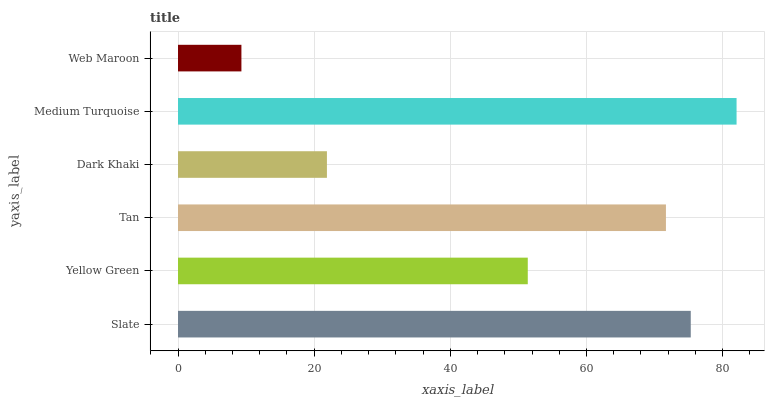Is Web Maroon the minimum?
Answer yes or no. Yes. Is Medium Turquoise the maximum?
Answer yes or no. Yes. Is Yellow Green the minimum?
Answer yes or no. No. Is Yellow Green the maximum?
Answer yes or no. No. Is Slate greater than Yellow Green?
Answer yes or no. Yes. Is Yellow Green less than Slate?
Answer yes or no. Yes. Is Yellow Green greater than Slate?
Answer yes or no. No. Is Slate less than Yellow Green?
Answer yes or no. No. Is Tan the high median?
Answer yes or no. Yes. Is Yellow Green the low median?
Answer yes or no. Yes. Is Web Maroon the high median?
Answer yes or no. No. Is Slate the low median?
Answer yes or no. No. 